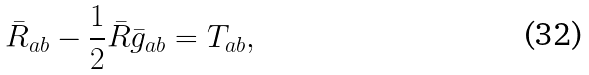<formula> <loc_0><loc_0><loc_500><loc_500>\bar { R } _ { a b } - \frac { 1 } { 2 } \bar { R } \bar { g } _ { a b } = T _ { a b } ,</formula> 